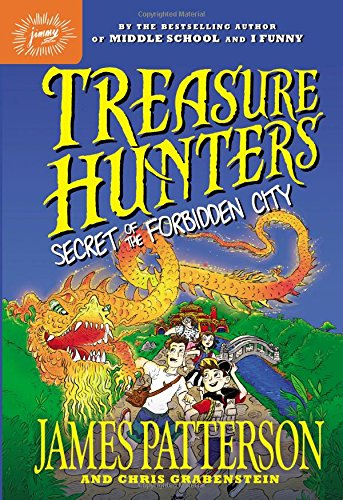Is this book related to Science & Math? No, this book does not delve into the Science & Math themes; it primarily revolves around mysteries and thrilling adventures. 